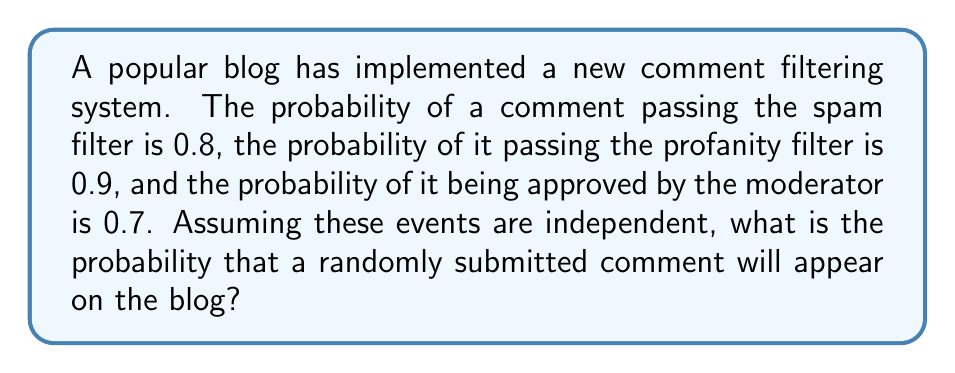Provide a solution to this math problem. To solve this problem, we need to use the concept of independent events in probability theory.

Let's define the events:
$A$: Comment passes the spam filter (P(A) = 0.8)
$B$: Comment passes the profanity filter (P(B) = 0.9)
$C$: Comment is approved by the moderator (P(C) = 0.7)

For a comment to appear on the blog, it must pass all three filters. Since these events are independent, we can multiply their individual probabilities to find the probability of all events occurring simultaneously.

The probability of all events occurring is:

$$P(A \cap B \cap C) = P(A) \cdot P(B) \cdot P(C)$$

Substituting the given probabilities:

$$P(A \cap B \cap C) = 0.8 \cdot 0.9 \cdot 0.7$$

Calculating:

$$P(A \cap B \cap C) = 0.504$$

Therefore, the probability that a randomly submitted comment will appear on the blog is 0.504 or 50.4%.
Answer: 0.504 or 50.4% 